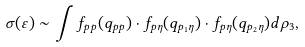Convert formula to latex. <formula><loc_0><loc_0><loc_500><loc_500>\sigma ( \varepsilon ) \sim \int f _ { p p } ( q _ { p p } ) \cdot f _ { p \eta } ( q _ { p _ { 1 } \eta } ) \cdot f _ { p \eta } ( q _ { p _ { 2 } \eta } ) d \rho _ { 3 } ,</formula> 